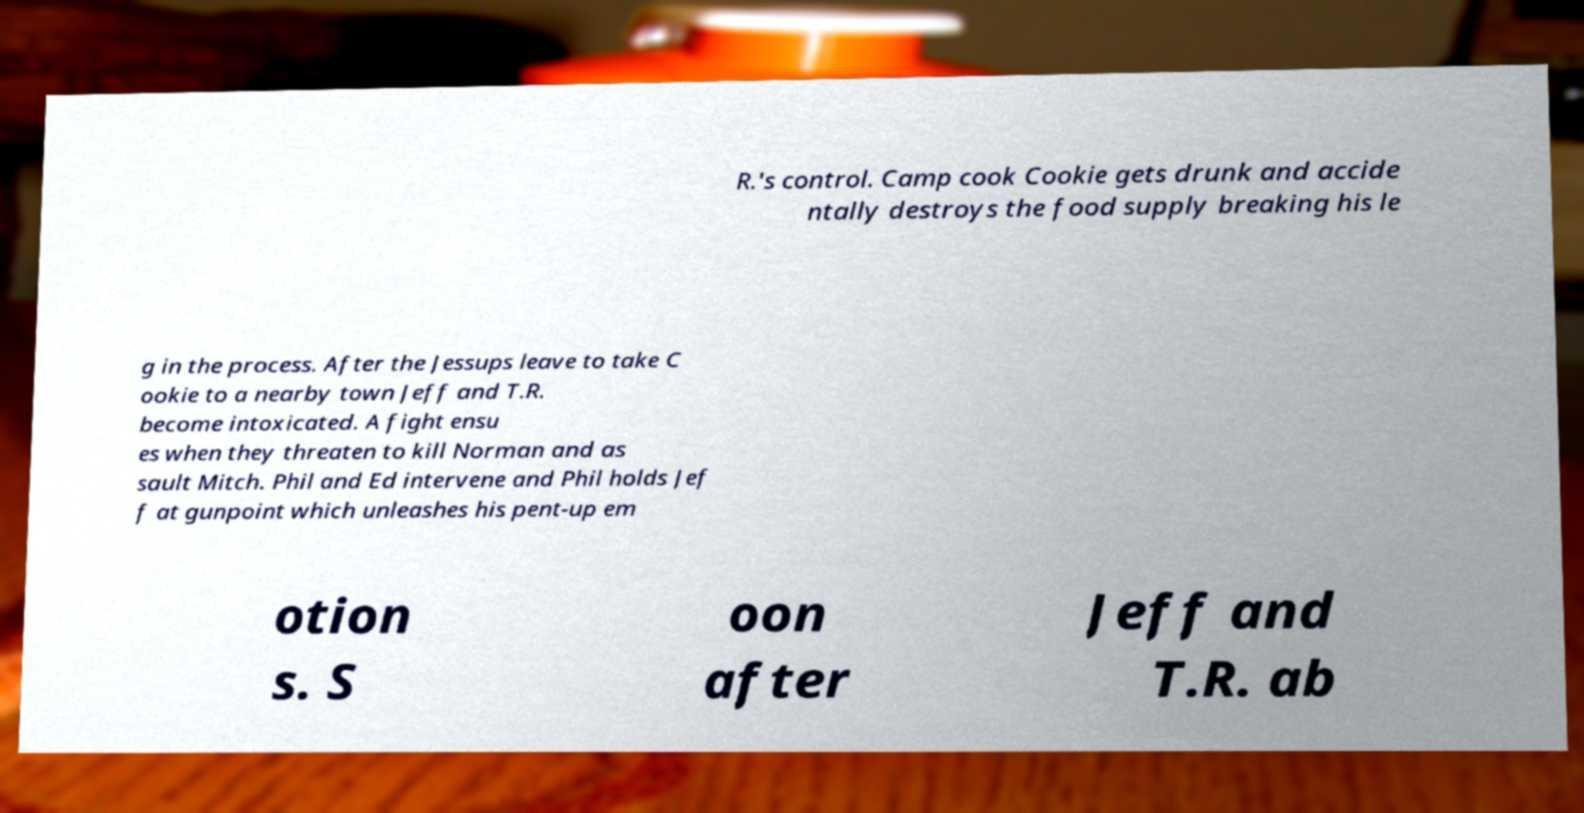What messages or text are displayed in this image? I need them in a readable, typed format. R.'s control. Camp cook Cookie gets drunk and accide ntally destroys the food supply breaking his le g in the process. After the Jessups leave to take C ookie to a nearby town Jeff and T.R. become intoxicated. A fight ensu es when they threaten to kill Norman and as sault Mitch. Phil and Ed intervene and Phil holds Jef f at gunpoint which unleashes his pent-up em otion s. S oon after Jeff and T.R. ab 